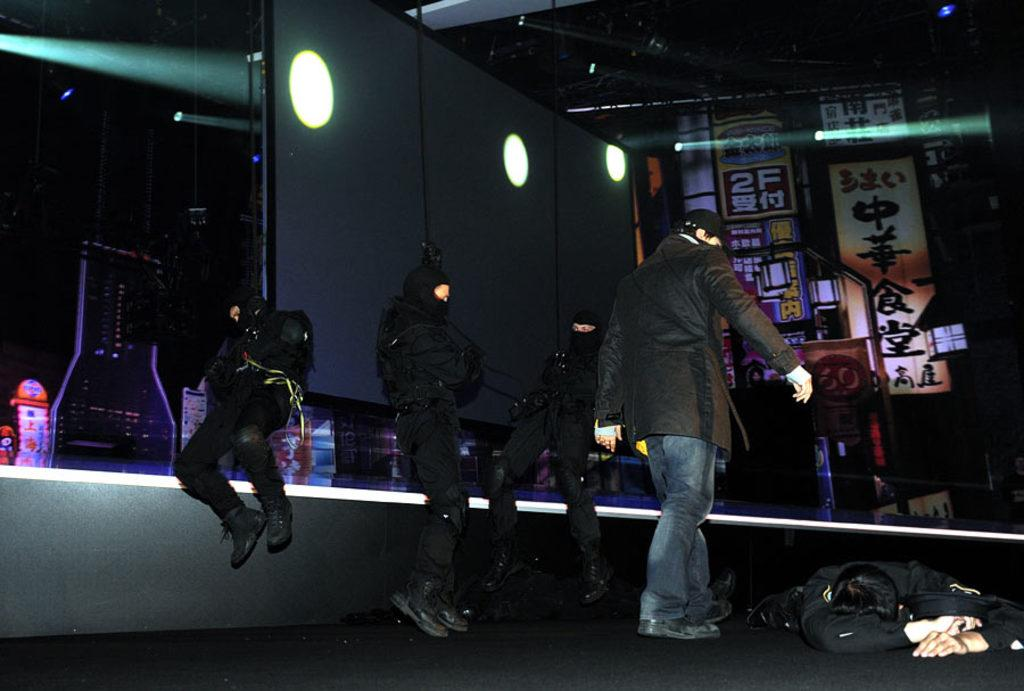How many people are standing in the image? There are three persons standing in the image. What is the position of the fourth person in the image? There is a person lying on the floor in the image. What can be seen in the image that might be used for illumination? There are focus lights in the image. What type of objects are present in the image? There are boards and a screen in the image. Can you tell me how many turkeys are visible in the image? There are no turkeys present in the image. What is the weight of the volcano in the image? There is no volcano present in the image, so its weight cannot be determined. 